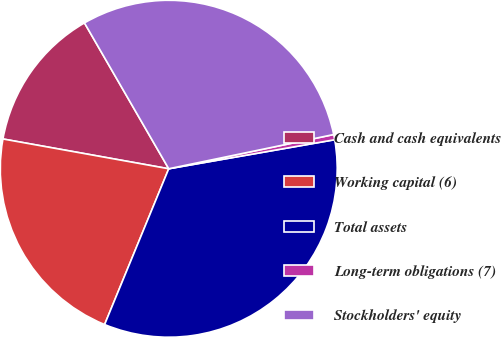Convert chart to OTSL. <chart><loc_0><loc_0><loc_500><loc_500><pie_chart><fcel>Cash and cash equivalents<fcel>Working capital (6)<fcel>Total assets<fcel>Long-term obligations (7)<fcel>Stockholders' equity<nl><fcel>13.83%<fcel>21.61%<fcel>33.97%<fcel>0.5%<fcel>30.08%<nl></chart> 